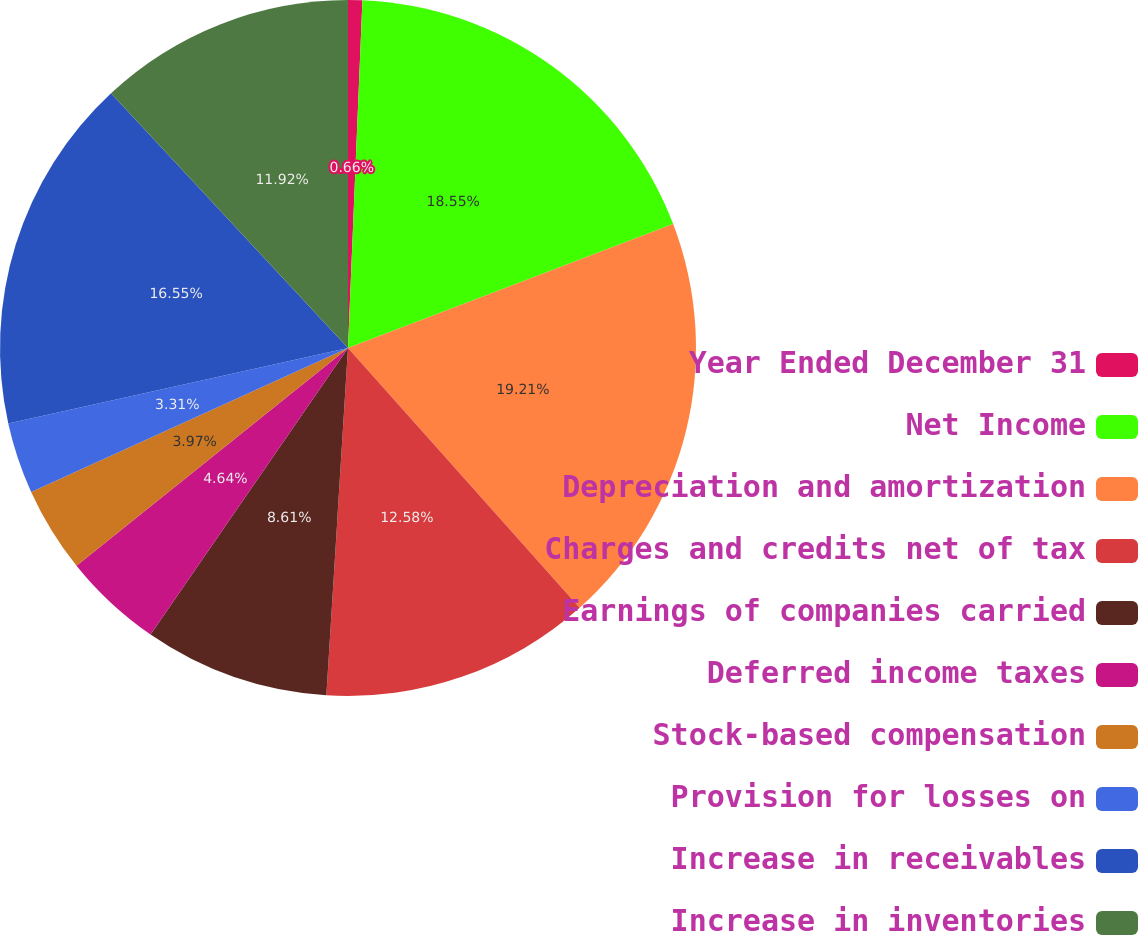Convert chart to OTSL. <chart><loc_0><loc_0><loc_500><loc_500><pie_chart><fcel>Year Ended December 31<fcel>Net Income<fcel>Depreciation and amortization<fcel>Charges and credits net of tax<fcel>Earnings of companies carried<fcel>Deferred income taxes<fcel>Stock-based compensation<fcel>Provision for losses on<fcel>Increase in receivables<fcel>Increase in inventories<nl><fcel>0.66%<fcel>18.54%<fcel>19.2%<fcel>12.58%<fcel>8.61%<fcel>4.64%<fcel>3.97%<fcel>3.31%<fcel>16.55%<fcel>11.92%<nl></chart> 